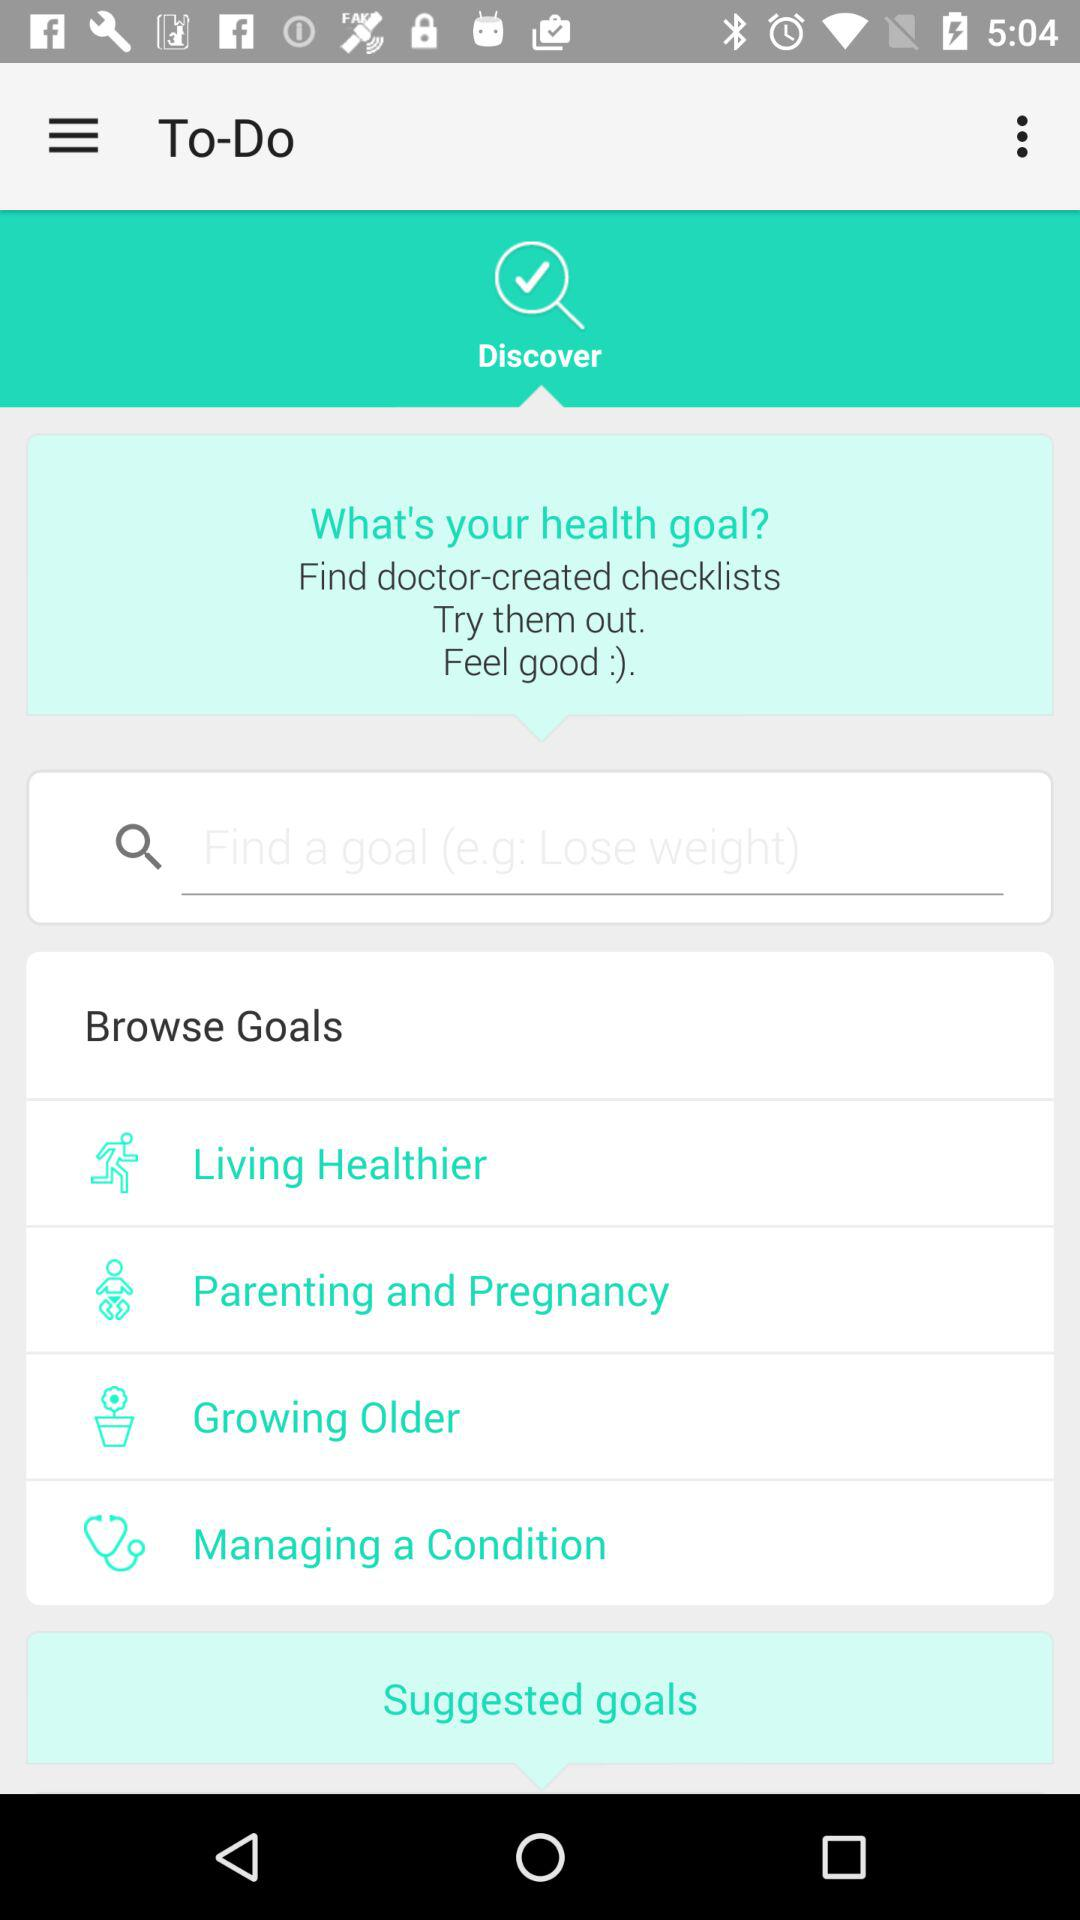How many suggested goals are there?
Answer the question using a single word or phrase. 4 